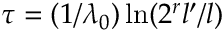<formula> <loc_0><loc_0><loc_500><loc_500>\tau = ( 1 / \lambda _ { 0 } ) \ln ( 2 ^ { r } l ^ { \prime } / l )</formula> 